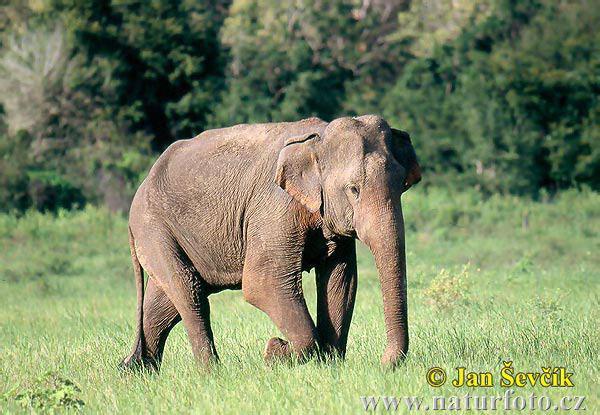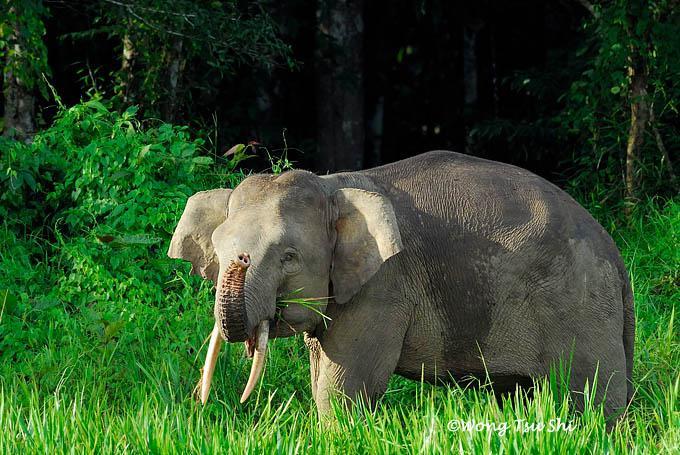The first image is the image on the left, the second image is the image on the right. Analyze the images presented: Is the assertion "The right image contains only one elephant." valid? Answer yes or no. Yes. The first image is the image on the left, the second image is the image on the right. For the images displayed, is the sentence "The right image contains a single elephant with large tusks." factually correct? Answer yes or no. Yes. 